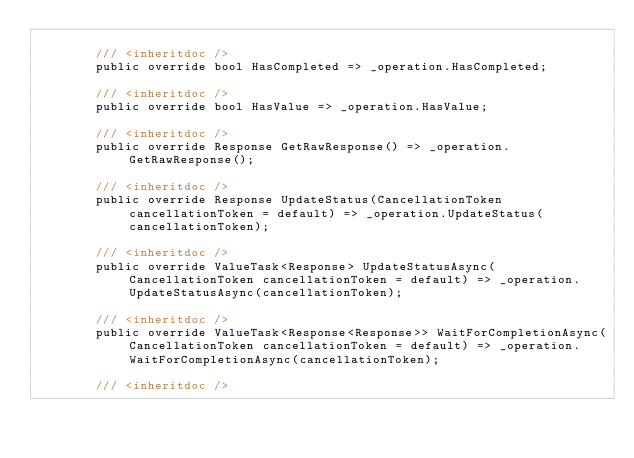<code> <loc_0><loc_0><loc_500><loc_500><_C#_>
        /// <inheritdoc />
        public override bool HasCompleted => _operation.HasCompleted;

        /// <inheritdoc />
        public override bool HasValue => _operation.HasValue;

        /// <inheritdoc />
        public override Response GetRawResponse() => _operation.GetRawResponse();

        /// <inheritdoc />
        public override Response UpdateStatus(CancellationToken cancellationToken = default) => _operation.UpdateStatus(cancellationToken);

        /// <inheritdoc />
        public override ValueTask<Response> UpdateStatusAsync(CancellationToken cancellationToken = default) => _operation.UpdateStatusAsync(cancellationToken);

        /// <inheritdoc />
        public override ValueTask<Response<Response>> WaitForCompletionAsync(CancellationToken cancellationToken = default) => _operation.WaitForCompletionAsync(cancellationToken);

        /// <inheritdoc /></code> 